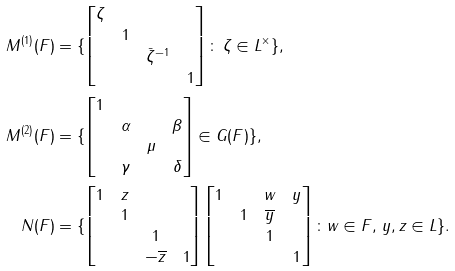<formula> <loc_0><loc_0><loc_500><loc_500>M ^ { ( 1 ) } ( F ) & = \{ \begin{bmatrix} \zeta \\ & 1 \\ & & \bar { \zeta } ^ { - 1 } \\ & & & 1 \end{bmatrix} \colon \, \zeta \in L ^ { \times } \} , \\ M ^ { ( 2 ) } ( F ) & = \{ \begin{bmatrix} 1 \\ & \alpha & & \beta \\ & & \mu \\ & \gamma & & \delta \end{bmatrix} \in G ( F ) \} , \\ N ( F ) & = \{ \begin{bmatrix} 1 & z & & \\ & 1 & & \\ & & 1 & \\ & & - \overline { z } & 1 \\ \end{bmatrix} \begin{bmatrix} 1 & & w & y \\ & 1 & \overline { y } & \\ & & 1 & \\ & & & 1 \\ \end{bmatrix} \colon w \in F , \, y , z \in L \} .</formula> 